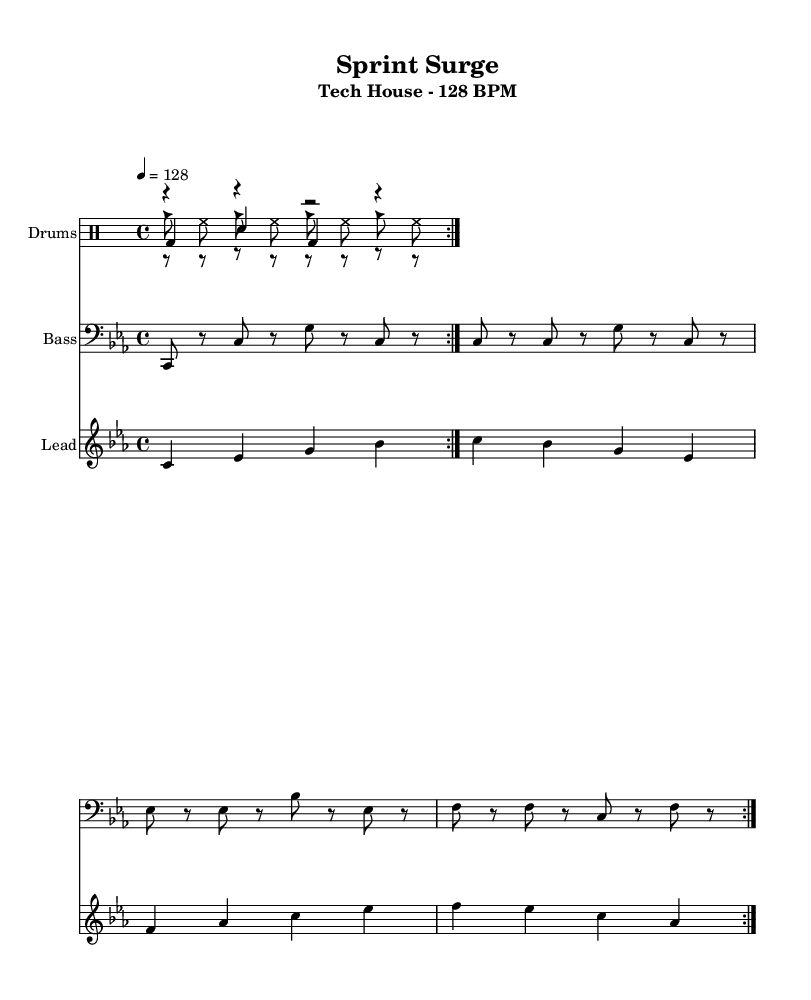What is the key signature of this music? The key signature is indicated by the use of flat signs on the staff. In this case, there are three flats present, confirming that the key is C minor.
Answer: C minor What is the time signature of this sheet music? The time signature is displayed at the beginning of the score. It shows 4 over 4, which means there are four beats in each measure and the quarter note gets one beat.
Answer: 4/4 What is the tempo marking of the piece? The tempo marking indicates the speed of the music. It is stated as quarter note equals 128 beats per minute, specifying how fast the music should be played.
Answer: 128 BPM How many measures are indicated in the kick drum pattern? By counting the repetitions indicated in the kick drum's rhythmic section, we see the symbol "volta 2," which signifies that the kick drum pattern repeats for two measures.
Answer: 2 What rhythmic pattern is used in the hi-hat section? The hi-hat section shows a pattern of eighth notes and rests alternately, represented clearly in the drummode. This reflects a common tech house style rhythm.
Answer: Eighth notes and rests How does the bass synth pattern support the sprint cadence? The bass synth pattern consists of consistent eighth note bursts, mimicking the quick, repeated footfalls of a sprinting cadence, which creates a feeling of urgency and driving rhythm.
Answer: Maintains urgency What unique characteristic defines this as Tech House music? Tech House often features repetitive rhythms and basslines designed for dance; this sheet music exhibits those traits with its driving bass and rhythmic percussion patterns throughout.
Answer: Repetitive rhythms 